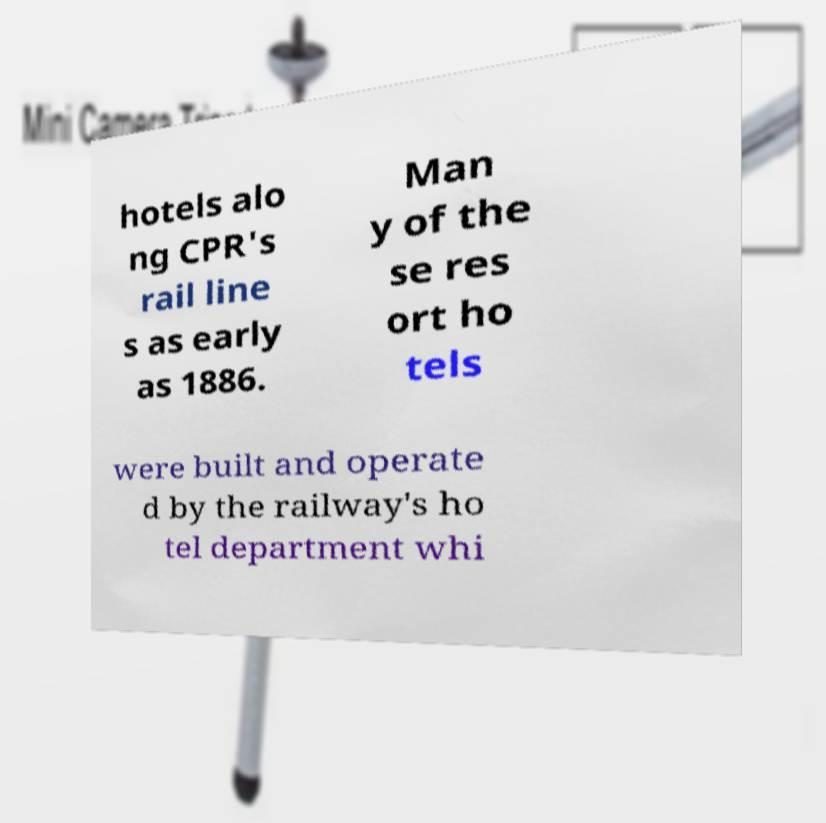Can you accurately transcribe the text from the provided image for me? hotels alo ng CPR's rail line s as early as 1886. Man y of the se res ort ho tels were built and operate d by the railway's ho tel department whi 